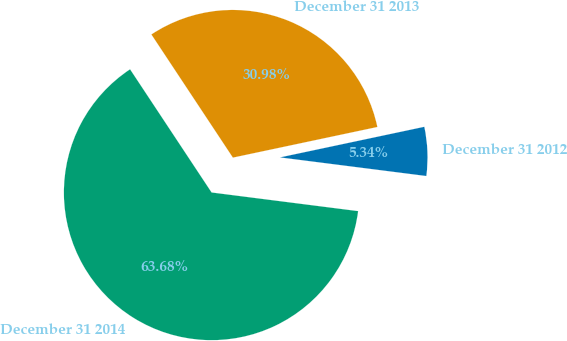Convert chart. <chart><loc_0><loc_0><loc_500><loc_500><pie_chart><fcel>December 31 2012<fcel>December 31 2013<fcel>December 31 2014<nl><fcel>5.34%<fcel>30.98%<fcel>63.68%<nl></chart> 